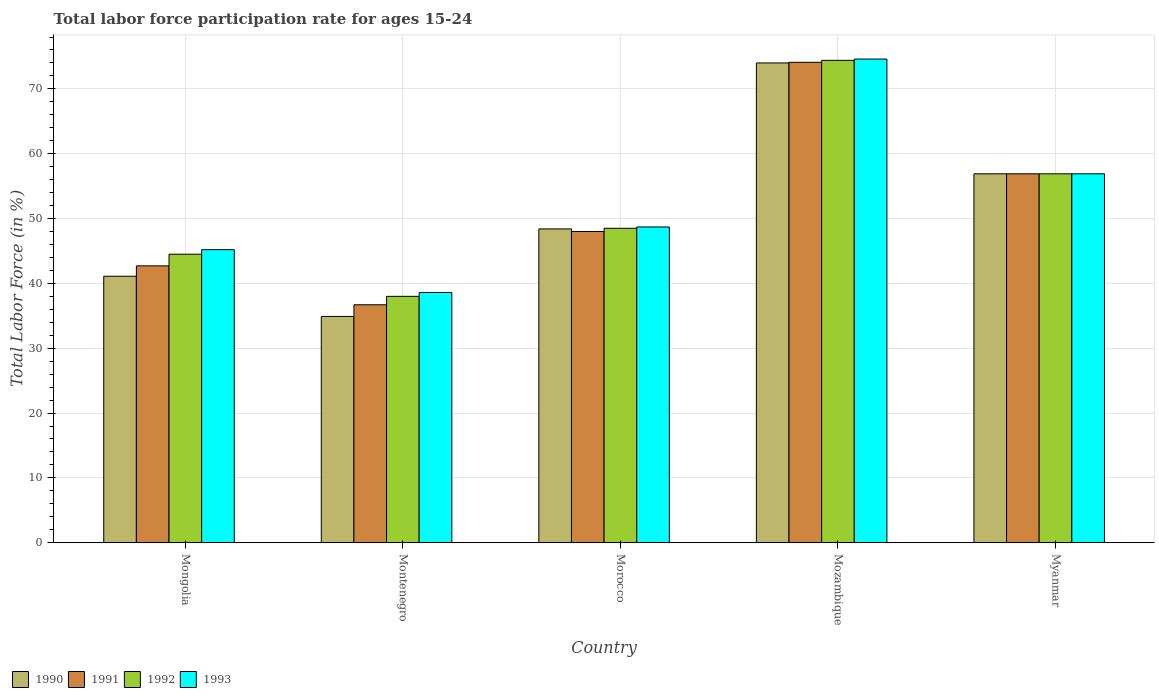How many different coloured bars are there?
Ensure brevity in your answer.  4. How many groups of bars are there?
Your answer should be compact. 5. How many bars are there on the 2nd tick from the left?
Provide a short and direct response. 4. What is the label of the 2nd group of bars from the left?
Ensure brevity in your answer.  Montenegro. In how many cases, is the number of bars for a given country not equal to the number of legend labels?
Provide a short and direct response. 0. What is the labor force participation rate in 1990 in Myanmar?
Make the answer very short. 56.9. Across all countries, what is the maximum labor force participation rate in 1990?
Keep it short and to the point. 74. Across all countries, what is the minimum labor force participation rate in 1993?
Provide a short and direct response. 38.6. In which country was the labor force participation rate in 1993 maximum?
Ensure brevity in your answer.  Mozambique. In which country was the labor force participation rate in 1992 minimum?
Make the answer very short. Montenegro. What is the total labor force participation rate in 1991 in the graph?
Make the answer very short. 258.4. What is the difference between the labor force participation rate in 1990 in Mongolia and that in Myanmar?
Offer a terse response. -15.8. What is the difference between the labor force participation rate in 1990 in Mozambique and the labor force participation rate in 1991 in Morocco?
Provide a short and direct response. 26. What is the average labor force participation rate in 1993 per country?
Your response must be concise. 52.8. In how many countries, is the labor force participation rate in 1992 greater than 10 %?
Your response must be concise. 5. What is the ratio of the labor force participation rate in 1993 in Morocco to that in Myanmar?
Keep it short and to the point. 0.86. Is the difference between the labor force participation rate in 1991 in Montenegro and Morocco greater than the difference between the labor force participation rate in 1990 in Montenegro and Morocco?
Make the answer very short. Yes. What is the difference between the highest and the second highest labor force participation rate in 1990?
Offer a terse response. -17.1. What is the difference between the highest and the lowest labor force participation rate in 1990?
Provide a succinct answer. 39.1. In how many countries, is the labor force participation rate in 1990 greater than the average labor force participation rate in 1990 taken over all countries?
Your answer should be very brief. 2. Is the sum of the labor force participation rate in 1990 in Mongolia and Myanmar greater than the maximum labor force participation rate in 1991 across all countries?
Give a very brief answer. Yes. Is it the case that in every country, the sum of the labor force participation rate in 1990 and labor force participation rate in 1992 is greater than the sum of labor force participation rate in 1991 and labor force participation rate in 1993?
Your answer should be compact. No. What does the 3rd bar from the right in Morocco represents?
Give a very brief answer. 1991. Is it the case that in every country, the sum of the labor force participation rate in 1991 and labor force participation rate in 1993 is greater than the labor force participation rate in 1990?
Provide a succinct answer. Yes. How many bars are there?
Make the answer very short. 20. What is the difference between two consecutive major ticks on the Y-axis?
Provide a short and direct response. 10. Does the graph contain any zero values?
Make the answer very short. No. Does the graph contain grids?
Your answer should be very brief. Yes. Where does the legend appear in the graph?
Provide a succinct answer. Bottom left. How many legend labels are there?
Ensure brevity in your answer.  4. How are the legend labels stacked?
Your answer should be very brief. Horizontal. What is the title of the graph?
Keep it short and to the point. Total labor force participation rate for ages 15-24. Does "1982" appear as one of the legend labels in the graph?
Your answer should be compact. No. What is the label or title of the X-axis?
Provide a succinct answer. Country. What is the label or title of the Y-axis?
Keep it short and to the point. Total Labor Force (in %). What is the Total Labor Force (in %) of 1990 in Mongolia?
Offer a very short reply. 41.1. What is the Total Labor Force (in %) in 1991 in Mongolia?
Offer a terse response. 42.7. What is the Total Labor Force (in %) in 1992 in Mongolia?
Your answer should be very brief. 44.5. What is the Total Labor Force (in %) in 1993 in Mongolia?
Make the answer very short. 45.2. What is the Total Labor Force (in %) in 1990 in Montenegro?
Give a very brief answer. 34.9. What is the Total Labor Force (in %) in 1991 in Montenegro?
Your answer should be very brief. 36.7. What is the Total Labor Force (in %) in 1993 in Montenegro?
Your answer should be very brief. 38.6. What is the Total Labor Force (in %) of 1990 in Morocco?
Keep it short and to the point. 48.4. What is the Total Labor Force (in %) of 1991 in Morocco?
Your response must be concise. 48. What is the Total Labor Force (in %) of 1992 in Morocco?
Your answer should be very brief. 48.5. What is the Total Labor Force (in %) of 1993 in Morocco?
Provide a succinct answer. 48.7. What is the Total Labor Force (in %) of 1991 in Mozambique?
Ensure brevity in your answer.  74.1. What is the Total Labor Force (in %) of 1992 in Mozambique?
Provide a short and direct response. 74.4. What is the Total Labor Force (in %) of 1993 in Mozambique?
Give a very brief answer. 74.6. What is the Total Labor Force (in %) of 1990 in Myanmar?
Give a very brief answer. 56.9. What is the Total Labor Force (in %) in 1991 in Myanmar?
Give a very brief answer. 56.9. What is the Total Labor Force (in %) in 1992 in Myanmar?
Your answer should be very brief. 56.9. What is the Total Labor Force (in %) of 1993 in Myanmar?
Provide a short and direct response. 56.9. Across all countries, what is the maximum Total Labor Force (in %) in 1990?
Ensure brevity in your answer.  74. Across all countries, what is the maximum Total Labor Force (in %) of 1991?
Give a very brief answer. 74.1. Across all countries, what is the maximum Total Labor Force (in %) of 1992?
Your response must be concise. 74.4. Across all countries, what is the maximum Total Labor Force (in %) of 1993?
Make the answer very short. 74.6. Across all countries, what is the minimum Total Labor Force (in %) of 1990?
Your answer should be compact. 34.9. Across all countries, what is the minimum Total Labor Force (in %) in 1991?
Offer a very short reply. 36.7. Across all countries, what is the minimum Total Labor Force (in %) in 1993?
Your response must be concise. 38.6. What is the total Total Labor Force (in %) of 1990 in the graph?
Offer a terse response. 255.3. What is the total Total Labor Force (in %) in 1991 in the graph?
Provide a succinct answer. 258.4. What is the total Total Labor Force (in %) in 1992 in the graph?
Give a very brief answer. 262.3. What is the total Total Labor Force (in %) in 1993 in the graph?
Offer a terse response. 264. What is the difference between the Total Labor Force (in %) of 1993 in Mongolia and that in Montenegro?
Offer a very short reply. 6.6. What is the difference between the Total Labor Force (in %) in 1990 in Mongolia and that in Morocco?
Your response must be concise. -7.3. What is the difference between the Total Labor Force (in %) in 1991 in Mongolia and that in Morocco?
Your answer should be compact. -5.3. What is the difference between the Total Labor Force (in %) of 1992 in Mongolia and that in Morocco?
Ensure brevity in your answer.  -4. What is the difference between the Total Labor Force (in %) in 1990 in Mongolia and that in Mozambique?
Provide a succinct answer. -32.9. What is the difference between the Total Labor Force (in %) in 1991 in Mongolia and that in Mozambique?
Your response must be concise. -31.4. What is the difference between the Total Labor Force (in %) in 1992 in Mongolia and that in Mozambique?
Give a very brief answer. -29.9. What is the difference between the Total Labor Force (in %) of 1993 in Mongolia and that in Mozambique?
Keep it short and to the point. -29.4. What is the difference between the Total Labor Force (in %) of 1990 in Mongolia and that in Myanmar?
Offer a terse response. -15.8. What is the difference between the Total Labor Force (in %) in 1991 in Montenegro and that in Morocco?
Your answer should be very brief. -11.3. What is the difference between the Total Labor Force (in %) of 1993 in Montenegro and that in Morocco?
Your answer should be very brief. -10.1. What is the difference between the Total Labor Force (in %) in 1990 in Montenegro and that in Mozambique?
Offer a very short reply. -39.1. What is the difference between the Total Labor Force (in %) of 1991 in Montenegro and that in Mozambique?
Your answer should be very brief. -37.4. What is the difference between the Total Labor Force (in %) of 1992 in Montenegro and that in Mozambique?
Offer a very short reply. -36.4. What is the difference between the Total Labor Force (in %) in 1993 in Montenegro and that in Mozambique?
Offer a terse response. -36. What is the difference between the Total Labor Force (in %) of 1990 in Montenegro and that in Myanmar?
Make the answer very short. -22. What is the difference between the Total Labor Force (in %) in 1991 in Montenegro and that in Myanmar?
Ensure brevity in your answer.  -20.2. What is the difference between the Total Labor Force (in %) of 1992 in Montenegro and that in Myanmar?
Provide a succinct answer. -18.9. What is the difference between the Total Labor Force (in %) in 1993 in Montenegro and that in Myanmar?
Offer a terse response. -18.3. What is the difference between the Total Labor Force (in %) of 1990 in Morocco and that in Mozambique?
Offer a very short reply. -25.6. What is the difference between the Total Labor Force (in %) of 1991 in Morocco and that in Mozambique?
Make the answer very short. -26.1. What is the difference between the Total Labor Force (in %) of 1992 in Morocco and that in Mozambique?
Your answer should be very brief. -25.9. What is the difference between the Total Labor Force (in %) of 1993 in Morocco and that in Mozambique?
Keep it short and to the point. -25.9. What is the difference between the Total Labor Force (in %) of 1992 in Morocco and that in Myanmar?
Make the answer very short. -8.4. What is the difference between the Total Labor Force (in %) in 1993 in Morocco and that in Myanmar?
Ensure brevity in your answer.  -8.2. What is the difference between the Total Labor Force (in %) in 1993 in Mozambique and that in Myanmar?
Offer a very short reply. 17.7. What is the difference between the Total Labor Force (in %) in 1990 in Mongolia and the Total Labor Force (in %) in 1993 in Montenegro?
Your answer should be compact. 2.5. What is the difference between the Total Labor Force (in %) in 1991 in Mongolia and the Total Labor Force (in %) in 1992 in Montenegro?
Provide a succinct answer. 4.7. What is the difference between the Total Labor Force (in %) of 1991 in Mongolia and the Total Labor Force (in %) of 1993 in Montenegro?
Keep it short and to the point. 4.1. What is the difference between the Total Labor Force (in %) in 1990 in Mongolia and the Total Labor Force (in %) in 1991 in Morocco?
Give a very brief answer. -6.9. What is the difference between the Total Labor Force (in %) in 1990 in Mongolia and the Total Labor Force (in %) in 1992 in Morocco?
Offer a very short reply. -7.4. What is the difference between the Total Labor Force (in %) of 1992 in Mongolia and the Total Labor Force (in %) of 1993 in Morocco?
Make the answer very short. -4.2. What is the difference between the Total Labor Force (in %) in 1990 in Mongolia and the Total Labor Force (in %) in 1991 in Mozambique?
Keep it short and to the point. -33. What is the difference between the Total Labor Force (in %) of 1990 in Mongolia and the Total Labor Force (in %) of 1992 in Mozambique?
Provide a short and direct response. -33.3. What is the difference between the Total Labor Force (in %) of 1990 in Mongolia and the Total Labor Force (in %) of 1993 in Mozambique?
Your response must be concise. -33.5. What is the difference between the Total Labor Force (in %) of 1991 in Mongolia and the Total Labor Force (in %) of 1992 in Mozambique?
Your response must be concise. -31.7. What is the difference between the Total Labor Force (in %) in 1991 in Mongolia and the Total Labor Force (in %) in 1993 in Mozambique?
Offer a very short reply. -31.9. What is the difference between the Total Labor Force (in %) in 1992 in Mongolia and the Total Labor Force (in %) in 1993 in Mozambique?
Provide a succinct answer. -30.1. What is the difference between the Total Labor Force (in %) in 1990 in Mongolia and the Total Labor Force (in %) in 1991 in Myanmar?
Ensure brevity in your answer.  -15.8. What is the difference between the Total Labor Force (in %) in 1990 in Mongolia and the Total Labor Force (in %) in 1992 in Myanmar?
Provide a short and direct response. -15.8. What is the difference between the Total Labor Force (in %) in 1990 in Mongolia and the Total Labor Force (in %) in 1993 in Myanmar?
Your answer should be very brief. -15.8. What is the difference between the Total Labor Force (in %) of 1992 in Mongolia and the Total Labor Force (in %) of 1993 in Myanmar?
Your answer should be very brief. -12.4. What is the difference between the Total Labor Force (in %) in 1990 in Montenegro and the Total Labor Force (in %) in 1993 in Morocco?
Your response must be concise. -13.8. What is the difference between the Total Labor Force (in %) in 1990 in Montenegro and the Total Labor Force (in %) in 1991 in Mozambique?
Your answer should be compact. -39.2. What is the difference between the Total Labor Force (in %) in 1990 in Montenegro and the Total Labor Force (in %) in 1992 in Mozambique?
Provide a short and direct response. -39.5. What is the difference between the Total Labor Force (in %) in 1990 in Montenegro and the Total Labor Force (in %) in 1993 in Mozambique?
Keep it short and to the point. -39.7. What is the difference between the Total Labor Force (in %) in 1991 in Montenegro and the Total Labor Force (in %) in 1992 in Mozambique?
Keep it short and to the point. -37.7. What is the difference between the Total Labor Force (in %) in 1991 in Montenegro and the Total Labor Force (in %) in 1993 in Mozambique?
Offer a terse response. -37.9. What is the difference between the Total Labor Force (in %) of 1992 in Montenegro and the Total Labor Force (in %) of 1993 in Mozambique?
Offer a very short reply. -36.6. What is the difference between the Total Labor Force (in %) in 1991 in Montenegro and the Total Labor Force (in %) in 1992 in Myanmar?
Ensure brevity in your answer.  -20.2. What is the difference between the Total Labor Force (in %) in 1991 in Montenegro and the Total Labor Force (in %) in 1993 in Myanmar?
Keep it short and to the point. -20.2. What is the difference between the Total Labor Force (in %) in 1992 in Montenegro and the Total Labor Force (in %) in 1993 in Myanmar?
Offer a very short reply. -18.9. What is the difference between the Total Labor Force (in %) of 1990 in Morocco and the Total Labor Force (in %) of 1991 in Mozambique?
Your answer should be compact. -25.7. What is the difference between the Total Labor Force (in %) of 1990 in Morocco and the Total Labor Force (in %) of 1992 in Mozambique?
Ensure brevity in your answer.  -26. What is the difference between the Total Labor Force (in %) in 1990 in Morocco and the Total Labor Force (in %) in 1993 in Mozambique?
Make the answer very short. -26.2. What is the difference between the Total Labor Force (in %) in 1991 in Morocco and the Total Labor Force (in %) in 1992 in Mozambique?
Provide a succinct answer. -26.4. What is the difference between the Total Labor Force (in %) in 1991 in Morocco and the Total Labor Force (in %) in 1993 in Mozambique?
Provide a short and direct response. -26.6. What is the difference between the Total Labor Force (in %) in 1992 in Morocco and the Total Labor Force (in %) in 1993 in Mozambique?
Offer a very short reply. -26.1. What is the difference between the Total Labor Force (in %) of 1990 in Mozambique and the Total Labor Force (in %) of 1991 in Myanmar?
Ensure brevity in your answer.  17.1. What is the difference between the Total Labor Force (in %) of 1990 in Mozambique and the Total Labor Force (in %) of 1993 in Myanmar?
Offer a very short reply. 17.1. What is the difference between the Total Labor Force (in %) of 1991 in Mozambique and the Total Labor Force (in %) of 1992 in Myanmar?
Provide a succinct answer. 17.2. What is the difference between the Total Labor Force (in %) in 1991 in Mozambique and the Total Labor Force (in %) in 1993 in Myanmar?
Your answer should be very brief. 17.2. What is the average Total Labor Force (in %) of 1990 per country?
Offer a terse response. 51.06. What is the average Total Labor Force (in %) of 1991 per country?
Provide a succinct answer. 51.68. What is the average Total Labor Force (in %) of 1992 per country?
Offer a terse response. 52.46. What is the average Total Labor Force (in %) of 1993 per country?
Your answer should be compact. 52.8. What is the difference between the Total Labor Force (in %) in 1990 and Total Labor Force (in %) in 1991 in Mongolia?
Ensure brevity in your answer.  -1.6. What is the difference between the Total Labor Force (in %) in 1991 and Total Labor Force (in %) in 1993 in Mongolia?
Your response must be concise. -2.5. What is the difference between the Total Labor Force (in %) of 1990 and Total Labor Force (in %) of 1993 in Montenegro?
Keep it short and to the point. -3.7. What is the difference between the Total Labor Force (in %) of 1991 and Total Labor Force (in %) of 1992 in Montenegro?
Provide a short and direct response. -1.3. What is the difference between the Total Labor Force (in %) of 1991 and Total Labor Force (in %) of 1993 in Montenegro?
Give a very brief answer. -1.9. What is the difference between the Total Labor Force (in %) in 1992 and Total Labor Force (in %) in 1993 in Montenegro?
Ensure brevity in your answer.  -0.6. What is the difference between the Total Labor Force (in %) in 1990 and Total Labor Force (in %) in 1993 in Morocco?
Offer a terse response. -0.3. What is the difference between the Total Labor Force (in %) of 1990 and Total Labor Force (in %) of 1991 in Mozambique?
Make the answer very short. -0.1. What is the difference between the Total Labor Force (in %) in 1990 and Total Labor Force (in %) in 1992 in Mozambique?
Provide a succinct answer. -0.4. What is the difference between the Total Labor Force (in %) of 1990 and Total Labor Force (in %) of 1993 in Mozambique?
Ensure brevity in your answer.  -0.6. What is the difference between the Total Labor Force (in %) of 1990 and Total Labor Force (in %) of 1992 in Myanmar?
Make the answer very short. 0. What is the difference between the Total Labor Force (in %) of 1991 and Total Labor Force (in %) of 1992 in Myanmar?
Your answer should be compact. 0. What is the difference between the Total Labor Force (in %) in 1991 and Total Labor Force (in %) in 1993 in Myanmar?
Ensure brevity in your answer.  0. What is the difference between the Total Labor Force (in %) of 1992 and Total Labor Force (in %) of 1993 in Myanmar?
Your response must be concise. 0. What is the ratio of the Total Labor Force (in %) of 1990 in Mongolia to that in Montenegro?
Give a very brief answer. 1.18. What is the ratio of the Total Labor Force (in %) in 1991 in Mongolia to that in Montenegro?
Ensure brevity in your answer.  1.16. What is the ratio of the Total Labor Force (in %) in 1992 in Mongolia to that in Montenegro?
Provide a succinct answer. 1.17. What is the ratio of the Total Labor Force (in %) in 1993 in Mongolia to that in Montenegro?
Your response must be concise. 1.17. What is the ratio of the Total Labor Force (in %) of 1990 in Mongolia to that in Morocco?
Offer a very short reply. 0.85. What is the ratio of the Total Labor Force (in %) in 1991 in Mongolia to that in Morocco?
Your answer should be very brief. 0.89. What is the ratio of the Total Labor Force (in %) of 1992 in Mongolia to that in Morocco?
Provide a succinct answer. 0.92. What is the ratio of the Total Labor Force (in %) of 1993 in Mongolia to that in Morocco?
Make the answer very short. 0.93. What is the ratio of the Total Labor Force (in %) in 1990 in Mongolia to that in Mozambique?
Make the answer very short. 0.56. What is the ratio of the Total Labor Force (in %) in 1991 in Mongolia to that in Mozambique?
Ensure brevity in your answer.  0.58. What is the ratio of the Total Labor Force (in %) of 1992 in Mongolia to that in Mozambique?
Ensure brevity in your answer.  0.6. What is the ratio of the Total Labor Force (in %) in 1993 in Mongolia to that in Mozambique?
Your answer should be very brief. 0.61. What is the ratio of the Total Labor Force (in %) in 1990 in Mongolia to that in Myanmar?
Keep it short and to the point. 0.72. What is the ratio of the Total Labor Force (in %) in 1991 in Mongolia to that in Myanmar?
Offer a terse response. 0.75. What is the ratio of the Total Labor Force (in %) of 1992 in Mongolia to that in Myanmar?
Provide a short and direct response. 0.78. What is the ratio of the Total Labor Force (in %) of 1993 in Mongolia to that in Myanmar?
Give a very brief answer. 0.79. What is the ratio of the Total Labor Force (in %) in 1990 in Montenegro to that in Morocco?
Your answer should be very brief. 0.72. What is the ratio of the Total Labor Force (in %) of 1991 in Montenegro to that in Morocco?
Keep it short and to the point. 0.76. What is the ratio of the Total Labor Force (in %) in 1992 in Montenegro to that in Morocco?
Your answer should be very brief. 0.78. What is the ratio of the Total Labor Force (in %) in 1993 in Montenegro to that in Morocco?
Provide a short and direct response. 0.79. What is the ratio of the Total Labor Force (in %) of 1990 in Montenegro to that in Mozambique?
Give a very brief answer. 0.47. What is the ratio of the Total Labor Force (in %) of 1991 in Montenegro to that in Mozambique?
Offer a terse response. 0.5. What is the ratio of the Total Labor Force (in %) of 1992 in Montenegro to that in Mozambique?
Give a very brief answer. 0.51. What is the ratio of the Total Labor Force (in %) of 1993 in Montenegro to that in Mozambique?
Provide a short and direct response. 0.52. What is the ratio of the Total Labor Force (in %) in 1990 in Montenegro to that in Myanmar?
Provide a succinct answer. 0.61. What is the ratio of the Total Labor Force (in %) of 1991 in Montenegro to that in Myanmar?
Offer a terse response. 0.65. What is the ratio of the Total Labor Force (in %) in 1992 in Montenegro to that in Myanmar?
Your answer should be compact. 0.67. What is the ratio of the Total Labor Force (in %) in 1993 in Montenegro to that in Myanmar?
Provide a succinct answer. 0.68. What is the ratio of the Total Labor Force (in %) in 1990 in Morocco to that in Mozambique?
Your answer should be very brief. 0.65. What is the ratio of the Total Labor Force (in %) in 1991 in Morocco to that in Mozambique?
Keep it short and to the point. 0.65. What is the ratio of the Total Labor Force (in %) in 1992 in Morocco to that in Mozambique?
Provide a short and direct response. 0.65. What is the ratio of the Total Labor Force (in %) of 1993 in Morocco to that in Mozambique?
Ensure brevity in your answer.  0.65. What is the ratio of the Total Labor Force (in %) of 1990 in Morocco to that in Myanmar?
Make the answer very short. 0.85. What is the ratio of the Total Labor Force (in %) in 1991 in Morocco to that in Myanmar?
Offer a terse response. 0.84. What is the ratio of the Total Labor Force (in %) in 1992 in Morocco to that in Myanmar?
Offer a terse response. 0.85. What is the ratio of the Total Labor Force (in %) in 1993 in Morocco to that in Myanmar?
Your answer should be compact. 0.86. What is the ratio of the Total Labor Force (in %) of 1990 in Mozambique to that in Myanmar?
Offer a terse response. 1.3. What is the ratio of the Total Labor Force (in %) in 1991 in Mozambique to that in Myanmar?
Give a very brief answer. 1.3. What is the ratio of the Total Labor Force (in %) of 1992 in Mozambique to that in Myanmar?
Your response must be concise. 1.31. What is the ratio of the Total Labor Force (in %) of 1993 in Mozambique to that in Myanmar?
Provide a succinct answer. 1.31. What is the difference between the highest and the second highest Total Labor Force (in %) of 1990?
Make the answer very short. 17.1. What is the difference between the highest and the second highest Total Labor Force (in %) in 1991?
Make the answer very short. 17.2. What is the difference between the highest and the second highest Total Labor Force (in %) of 1993?
Make the answer very short. 17.7. What is the difference between the highest and the lowest Total Labor Force (in %) in 1990?
Your answer should be very brief. 39.1. What is the difference between the highest and the lowest Total Labor Force (in %) in 1991?
Keep it short and to the point. 37.4. What is the difference between the highest and the lowest Total Labor Force (in %) in 1992?
Your answer should be very brief. 36.4. What is the difference between the highest and the lowest Total Labor Force (in %) of 1993?
Provide a short and direct response. 36. 